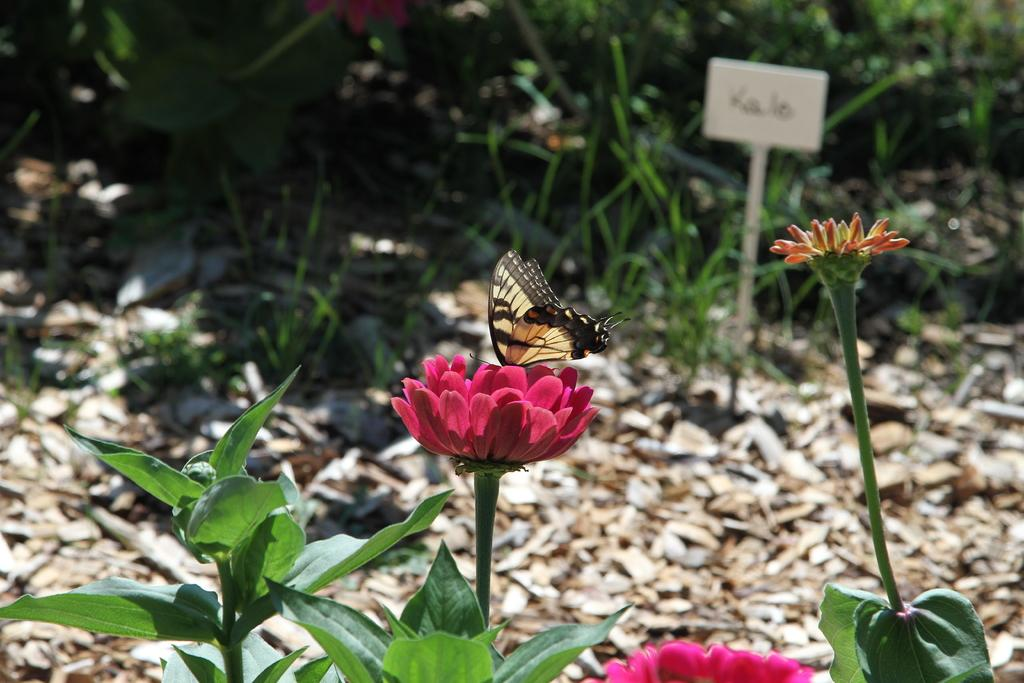What type of plants can be seen in the image? There are plants with flowers in the image. Can you describe any specific activity involving the plants? Yes, there is a butterfly on a flower. What can be observed about the background of the image? The background of the image is blurry. What else is visible in the background? There is a board and grass present in the background. Are there any other plants visible in the background? Yes, there are plants in the background. What type of rod can be seen holding up the substance in the image? A: There is no rod or substance present in the image; it features plants with flowers and a butterfly on a flower. What color is the blood on the butterfly's wings in the image? There is no blood present on the butterfly's wings in the image. 